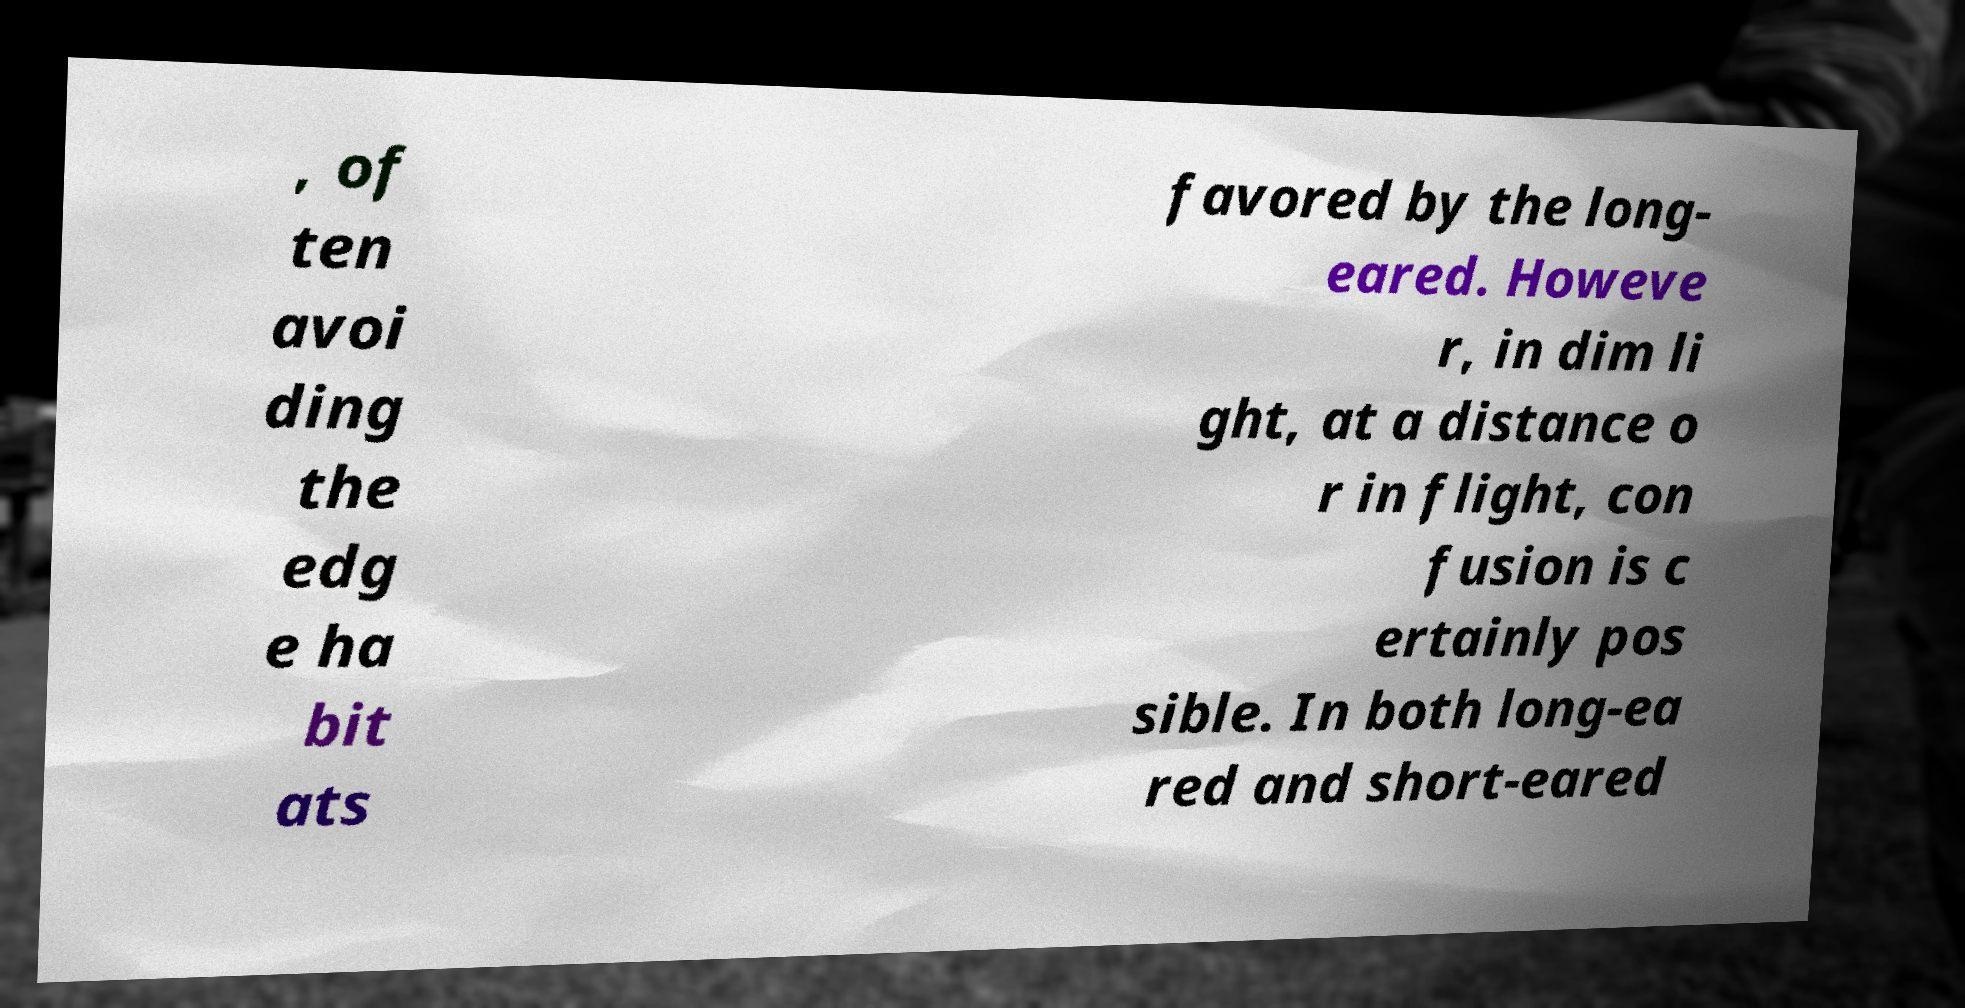Can you accurately transcribe the text from the provided image for me? , of ten avoi ding the edg e ha bit ats favored by the long- eared. Howeve r, in dim li ght, at a distance o r in flight, con fusion is c ertainly pos sible. In both long-ea red and short-eared 